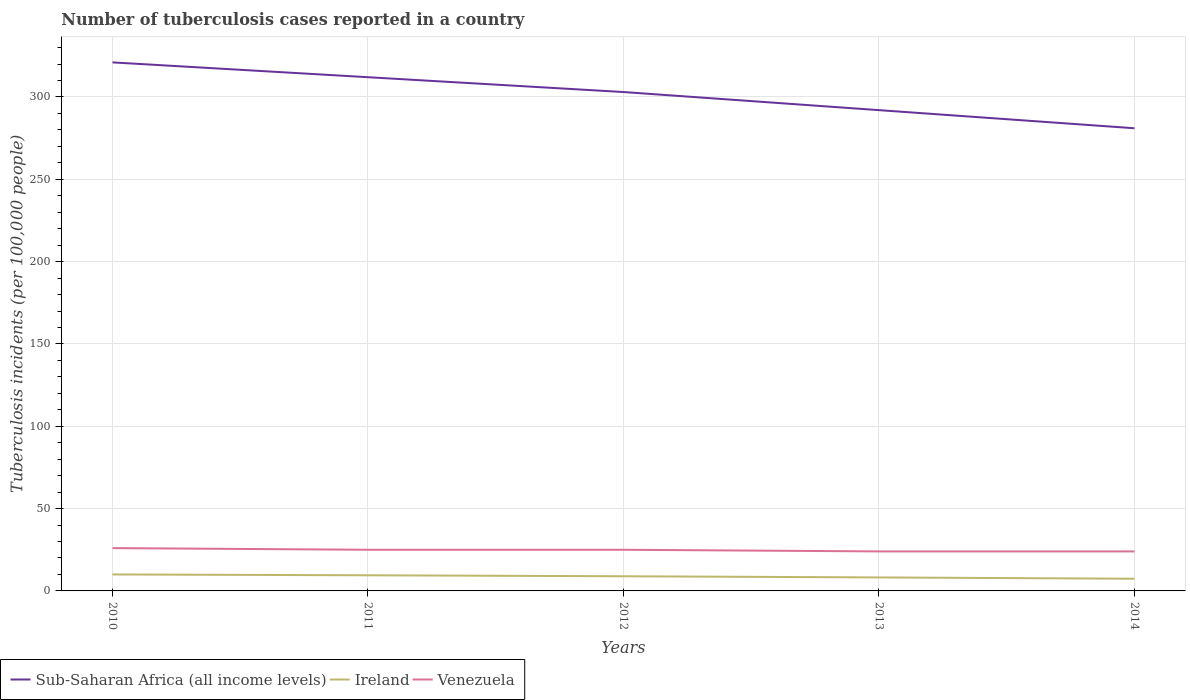Across all years, what is the maximum number of tuberculosis cases reported in in Sub-Saharan Africa (all income levels)?
Offer a terse response. 281. What is the total number of tuberculosis cases reported in in Sub-Saharan Africa (all income levels) in the graph?
Your answer should be compact. 9. What is the difference between the highest and the second highest number of tuberculosis cases reported in in Sub-Saharan Africa (all income levels)?
Your response must be concise. 40. What is the difference between the highest and the lowest number of tuberculosis cases reported in in Ireland?
Your response must be concise. 3. Is the number of tuberculosis cases reported in in Venezuela strictly greater than the number of tuberculosis cases reported in in Sub-Saharan Africa (all income levels) over the years?
Your answer should be very brief. Yes. How many years are there in the graph?
Make the answer very short. 5. What is the difference between two consecutive major ticks on the Y-axis?
Offer a very short reply. 50. How many legend labels are there?
Offer a terse response. 3. What is the title of the graph?
Provide a short and direct response. Number of tuberculosis cases reported in a country. Does "Togo" appear as one of the legend labels in the graph?
Keep it short and to the point. No. What is the label or title of the Y-axis?
Your response must be concise. Tuberculosis incidents (per 100,0 people). What is the Tuberculosis incidents (per 100,000 people) of Sub-Saharan Africa (all income levels) in 2010?
Give a very brief answer. 321. What is the Tuberculosis incidents (per 100,000 people) in Sub-Saharan Africa (all income levels) in 2011?
Keep it short and to the point. 312. What is the Tuberculosis incidents (per 100,000 people) of Ireland in 2011?
Provide a succinct answer. 9.5. What is the Tuberculosis incidents (per 100,000 people) of Sub-Saharan Africa (all income levels) in 2012?
Offer a terse response. 303. What is the Tuberculosis incidents (per 100,000 people) in Sub-Saharan Africa (all income levels) in 2013?
Provide a short and direct response. 292. What is the Tuberculosis incidents (per 100,000 people) of Ireland in 2013?
Offer a terse response. 8.2. What is the Tuberculosis incidents (per 100,000 people) in Venezuela in 2013?
Provide a short and direct response. 24. What is the Tuberculosis incidents (per 100,000 people) in Sub-Saharan Africa (all income levels) in 2014?
Make the answer very short. 281. Across all years, what is the maximum Tuberculosis incidents (per 100,000 people) in Sub-Saharan Africa (all income levels)?
Make the answer very short. 321. Across all years, what is the maximum Tuberculosis incidents (per 100,000 people) in Venezuela?
Provide a short and direct response. 26. Across all years, what is the minimum Tuberculosis incidents (per 100,000 people) in Sub-Saharan Africa (all income levels)?
Make the answer very short. 281. What is the total Tuberculosis incidents (per 100,000 people) of Sub-Saharan Africa (all income levels) in the graph?
Offer a very short reply. 1509. What is the total Tuberculosis incidents (per 100,000 people) of Venezuela in the graph?
Your response must be concise. 124. What is the difference between the Tuberculosis incidents (per 100,000 people) in Ireland in 2010 and that in 2011?
Your answer should be compact. 0.5. What is the difference between the Tuberculosis incidents (per 100,000 people) of Sub-Saharan Africa (all income levels) in 2010 and that in 2013?
Your response must be concise. 29. What is the difference between the Tuberculosis incidents (per 100,000 people) of Ireland in 2010 and that in 2013?
Keep it short and to the point. 1.8. What is the difference between the Tuberculosis incidents (per 100,000 people) of Sub-Saharan Africa (all income levels) in 2010 and that in 2014?
Offer a terse response. 40. What is the difference between the Tuberculosis incidents (per 100,000 people) in Sub-Saharan Africa (all income levels) in 2011 and that in 2012?
Give a very brief answer. 9. What is the difference between the Tuberculosis incidents (per 100,000 people) in Venezuela in 2011 and that in 2012?
Your answer should be very brief. 0. What is the difference between the Tuberculosis incidents (per 100,000 people) of Venezuela in 2011 and that in 2013?
Provide a succinct answer. 1. What is the difference between the Tuberculosis incidents (per 100,000 people) in Sub-Saharan Africa (all income levels) in 2011 and that in 2014?
Give a very brief answer. 31. What is the difference between the Tuberculosis incidents (per 100,000 people) of Venezuela in 2011 and that in 2014?
Your answer should be compact. 1. What is the difference between the Tuberculosis incidents (per 100,000 people) in Venezuela in 2012 and that in 2014?
Your response must be concise. 1. What is the difference between the Tuberculosis incidents (per 100,000 people) of Sub-Saharan Africa (all income levels) in 2013 and that in 2014?
Offer a very short reply. 11. What is the difference between the Tuberculosis incidents (per 100,000 people) of Ireland in 2013 and that in 2014?
Your answer should be compact. 0.8. What is the difference between the Tuberculosis incidents (per 100,000 people) of Venezuela in 2013 and that in 2014?
Your response must be concise. 0. What is the difference between the Tuberculosis incidents (per 100,000 people) in Sub-Saharan Africa (all income levels) in 2010 and the Tuberculosis incidents (per 100,000 people) in Ireland in 2011?
Make the answer very short. 311.5. What is the difference between the Tuberculosis incidents (per 100,000 people) of Sub-Saharan Africa (all income levels) in 2010 and the Tuberculosis incidents (per 100,000 people) of Venezuela in 2011?
Give a very brief answer. 296. What is the difference between the Tuberculosis incidents (per 100,000 people) in Ireland in 2010 and the Tuberculosis incidents (per 100,000 people) in Venezuela in 2011?
Your answer should be compact. -15. What is the difference between the Tuberculosis incidents (per 100,000 people) in Sub-Saharan Africa (all income levels) in 2010 and the Tuberculosis incidents (per 100,000 people) in Ireland in 2012?
Your answer should be compact. 312.1. What is the difference between the Tuberculosis incidents (per 100,000 people) of Sub-Saharan Africa (all income levels) in 2010 and the Tuberculosis incidents (per 100,000 people) of Venezuela in 2012?
Offer a terse response. 296. What is the difference between the Tuberculosis incidents (per 100,000 people) in Sub-Saharan Africa (all income levels) in 2010 and the Tuberculosis incidents (per 100,000 people) in Ireland in 2013?
Ensure brevity in your answer.  312.8. What is the difference between the Tuberculosis incidents (per 100,000 people) in Sub-Saharan Africa (all income levels) in 2010 and the Tuberculosis incidents (per 100,000 people) in Venezuela in 2013?
Provide a succinct answer. 297. What is the difference between the Tuberculosis incidents (per 100,000 people) in Ireland in 2010 and the Tuberculosis incidents (per 100,000 people) in Venezuela in 2013?
Keep it short and to the point. -14. What is the difference between the Tuberculosis incidents (per 100,000 people) in Sub-Saharan Africa (all income levels) in 2010 and the Tuberculosis incidents (per 100,000 people) in Ireland in 2014?
Your response must be concise. 313.6. What is the difference between the Tuberculosis incidents (per 100,000 people) in Sub-Saharan Africa (all income levels) in 2010 and the Tuberculosis incidents (per 100,000 people) in Venezuela in 2014?
Your response must be concise. 297. What is the difference between the Tuberculosis incidents (per 100,000 people) of Sub-Saharan Africa (all income levels) in 2011 and the Tuberculosis incidents (per 100,000 people) of Ireland in 2012?
Provide a short and direct response. 303.1. What is the difference between the Tuberculosis incidents (per 100,000 people) of Sub-Saharan Africa (all income levels) in 2011 and the Tuberculosis incidents (per 100,000 people) of Venezuela in 2012?
Your answer should be compact. 287. What is the difference between the Tuberculosis incidents (per 100,000 people) of Ireland in 2011 and the Tuberculosis incidents (per 100,000 people) of Venezuela in 2012?
Your answer should be compact. -15.5. What is the difference between the Tuberculosis incidents (per 100,000 people) in Sub-Saharan Africa (all income levels) in 2011 and the Tuberculosis incidents (per 100,000 people) in Ireland in 2013?
Ensure brevity in your answer.  303.8. What is the difference between the Tuberculosis incidents (per 100,000 people) of Sub-Saharan Africa (all income levels) in 2011 and the Tuberculosis incidents (per 100,000 people) of Venezuela in 2013?
Your answer should be very brief. 288. What is the difference between the Tuberculosis incidents (per 100,000 people) in Sub-Saharan Africa (all income levels) in 2011 and the Tuberculosis incidents (per 100,000 people) in Ireland in 2014?
Make the answer very short. 304.6. What is the difference between the Tuberculosis incidents (per 100,000 people) in Sub-Saharan Africa (all income levels) in 2011 and the Tuberculosis incidents (per 100,000 people) in Venezuela in 2014?
Make the answer very short. 288. What is the difference between the Tuberculosis incidents (per 100,000 people) of Ireland in 2011 and the Tuberculosis incidents (per 100,000 people) of Venezuela in 2014?
Make the answer very short. -14.5. What is the difference between the Tuberculosis incidents (per 100,000 people) of Sub-Saharan Africa (all income levels) in 2012 and the Tuberculosis incidents (per 100,000 people) of Ireland in 2013?
Your response must be concise. 294.8. What is the difference between the Tuberculosis incidents (per 100,000 people) in Sub-Saharan Africa (all income levels) in 2012 and the Tuberculosis incidents (per 100,000 people) in Venezuela in 2013?
Provide a short and direct response. 279. What is the difference between the Tuberculosis incidents (per 100,000 people) in Ireland in 2012 and the Tuberculosis incidents (per 100,000 people) in Venezuela in 2013?
Keep it short and to the point. -15.1. What is the difference between the Tuberculosis incidents (per 100,000 people) in Sub-Saharan Africa (all income levels) in 2012 and the Tuberculosis incidents (per 100,000 people) in Ireland in 2014?
Your answer should be very brief. 295.6. What is the difference between the Tuberculosis incidents (per 100,000 people) of Sub-Saharan Africa (all income levels) in 2012 and the Tuberculosis incidents (per 100,000 people) of Venezuela in 2014?
Give a very brief answer. 279. What is the difference between the Tuberculosis incidents (per 100,000 people) of Ireland in 2012 and the Tuberculosis incidents (per 100,000 people) of Venezuela in 2014?
Your answer should be very brief. -15.1. What is the difference between the Tuberculosis incidents (per 100,000 people) in Sub-Saharan Africa (all income levels) in 2013 and the Tuberculosis incidents (per 100,000 people) in Ireland in 2014?
Keep it short and to the point. 284.6. What is the difference between the Tuberculosis incidents (per 100,000 people) of Sub-Saharan Africa (all income levels) in 2013 and the Tuberculosis incidents (per 100,000 people) of Venezuela in 2014?
Provide a succinct answer. 268. What is the difference between the Tuberculosis incidents (per 100,000 people) of Ireland in 2013 and the Tuberculosis incidents (per 100,000 people) of Venezuela in 2014?
Make the answer very short. -15.8. What is the average Tuberculosis incidents (per 100,000 people) of Sub-Saharan Africa (all income levels) per year?
Your response must be concise. 301.8. What is the average Tuberculosis incidents (per 100,000 people) in Venezuela per year?
Keep it short and to the point. 24.8. In the year 2010, what is the difference between the Tuberculosis incidents (per 100,000 people) of Sub-Saharan Africa (all income levels) and Tuberculosis incidents (per 100,000 people) of Ireland?
Your response must be concise. 311. In the year 2010, what is the difference between the Tuberculosis incidents (per 100,000 people) of Sub-Saharan Africa (all income levels) and Tuberculosis incidents (per 100,000 people) of Venezuela?
Ensure brevity in your answer.  295. In the year 2011, what is the difference between the Tuberculosis incidents (per 100,000 people) in Sub-Saharan Africa (all income levels) and Tuberculosis incidents (per 100,000 people) in Ireland?
Ensure brevity in your answer.  302.5. In the year 2011, what is the difference between the Tuberculosis incidents (per 100,000 people) in Sub-Saharan Africa (all income levels) and Tuberculosis incidents (per 100,000 people) in Venezuela?
Give a very brief answer. 287. In the year 2011, what is the difference between the Tuberculosis incidents (per 100,000 people) in Ireland and Tuberculosis incidents (per 100,000 people) in Venezuela?
Ensure brevity in your answer.  -15.5. In the year 2012, what is the difference between the Tuberculosis incidents (per 100,000 people) of Sub-Saharan Africa (all income levels) and Tuberculosis incidents (per 100,000 people) of Ireland?
Your answer should be compact. 294.1. In the year 2012, what is the difference between the Tuberculosis incidents (per 100,000 people) in Sub-Saharan Africa (all income levels) and Tuberculosis incidents (per 100,000 people) in Venezuela?
Give a very brief answer. 278. In the year 2012, what is the difference between the Tuberculosis incidents (per 100,000 people) in Ireland and Tuberculosis incidents (per 100,000 people) in Venezuela?
Offer a terse response. -16.1. In the year 2013, what is the difference between the Tuberculosis incidents (per 100,000 people) of Sub-Saharan Africa (all income levels) and Tuberculosis incidents (per 100,000 people) of Ireland?
Offer a terse response. 283.8. In the year 2013, what is the difference between the Tuberculosis incidents (per 100,000 people) in Sub-Saharan Africa (all income levels) and Tuberculosis incidents (per 100,000 people) in Venezuela?
Your answer should be very brief. 268. In the year 2013, what is the difference between the Tuberculosis incidents (per 100,000 people) of Ireland and Tuberculosis incidents (per 100,000 people) of Venezuela?
Offer a terse response. -15.8. In the year 2014, what is the difference between the Tuberculosis incidents (per 100,000 people) of Sub-Saharan Africa (all income levels) and Tuberculosis incidents (per 100,000 people) of Ireland?
Your answer should be very brief. 273.6. In the year 2014, what is the difference between the Tuberculosis incidents (per 100,000 people) in Sub-Saharan Africa (all income levels) and Tuberculosis incidents (per 100,000 people) in Venezuela?
Provide a succinct answer. 257. In the year 2014, what is the difference between the Tuberculosis incidents (per 100,000 people) of Ireland and Tuberculosis incidents (per 100,000 people) of Venezuela?
Ensure brevity in your answer.  -16.6. What is the ratio of the Tuberculosis incidents (per 100,000 people) of Sub-Saharan Africa (all income levels) in 2010 to that in 2011?
Your answer should be compact. 1.03. What is the ratio of the Tuberculosis incidents (per 100,000 people) in Ireland in 2010 to that in 2011?
Ensure brevity in your answer.  1.05. What is the ratio of the Tuberculosis incidents (per 100,000 people) in Sub-Saharan Africa (all income levels) in 2010 to that in 2012?
Ensure brevity in your answer.  1.06. What is the ratio of the Tuberculosis incidents (per 100,000 people) of Ireland in 2010 to that in 2012?
Provide a succinct answer. 1.12. What is the ratio of the Tuberculosis incidents (per 100,000 people) of Sub-Saharan Africa (all income levels) in 2010 to that in 2013?
Offer a terse response. 1.1. What is the ratio of the Tuberculosis incidents (per 100,000 people) in Ireland in 2010 to that in 2013?
Provide a succinct answer. 1.22. What is the ratio of the Tuberculosis incidents (per 100,000 people) in Sub-Saharan Africa (all income levels) in 2010 to that in 2014?
Offer a terse response. 1.14. What is the ratio of the Tuberculosis incidents (per 100,000 people) of Ireland in 2010 to that in 2014?
Keep it short and to the point. 1.35. What is the ratio of the Tuberculosis incidents (per 100,000 people) of Venezuela in 2010 to that in 2014?
Provide a succinct answer. 1.08. What is the ratio of the Tuberculosis incidents (per 100,000 people) in Sub-Saharan Africa (all income levels) in 2011 to that in 2012?
Your answer should be very brief. 1.03. What is the ratio of the Tuberculosis incidents (per 100,000 people) in Ireland in 2011 to that in 2012?
Your answer should be very brief. 1.07. What is the ratio of the Tuberculosis incidents (per 100,000 people) of Sub-Saharan Africa (all income levels) in 2011 to that in 2013?
Offer a terse response. 1.07. What is the ratio of the Tuberculosis incidents (per 100,000 people) of Ireland in 2011 to that in 2013?
Give a very brief answer. 1.16. What is the ratio of the Tuberculosis incidents (per 100,000 people) in Venezuela in 2011 to that in 2013?
Provide a short and direct response. 1.04. What is the ratio of the Tuberculosis incidents (per 100,000 people) in Sub-Saharan Africa (all income levels) in 2011 to that in 2014?
Your response must be concise. 1.11. What is the ratio of the Tuberculosis incidents (per 100,000 people) in Ireland in 2011 to that in 2014?
Offer a terse response. 1.28. What is the ratio of the Tuberculosis incidents (per 100,000 people) of Venezuela in 2011 to that in 2014?
Offer a very short reply. 1.04. What is the ratio of the Tuberculosis incidents (per 100,000 people) in Sub-Saharan Africa (all income levels) in 2012 to that in 2013?
Make the answer very short. 1.04. What is the ratio of the Tuberculosis incidents (per 100,000 people) in Ireland in 2012 to that in 2013?
Offer a very short reply. 1.09. What is the ratio of the Tuberculosis incidents (per 100,000 people) of Venezuela in 2012 to that in 2013?
Your answer should be compact. 1.04. What is the ratio of the Tuberculosis incidents (per 100,000 people) in Sub-Saharan Africa (all income levels) in 2012 to that in 2014?
Offer a terse response. 1.08. What is the ratio of the Tuberculosis incidents (per 100,000 people) in Ireland in 2012 to that in 2014?
Provide a succinct answer. 1.2. What is the ratio of the Tuberculosis incidents (per 100,000 people) in Venezuela in 2012 to that in 2014?
Offer a terse response. 1.04. What is the ratio of the Tuberculosis incidents (per 100,000 people) of Sub-Saharan Africa (all income levels) in 2013 to that in 2014?
Provide a succinct answer. 1.04. What is the ratio of the Tuberculosis incidents (per 100,000 people) in Ireland in 2013 to that in 2014?
Offer a terse response. 1.11. What is the ratio of the Tuberculosis incidents (per 100,000 people) in Venezuela in 2013 to that in 2014?
Make the answer very short. 1. What is the difference between the highest and the second highest Tuberculosis incidents (per 100,000 people) of Sub-Saharan Africa (all income levels)?
Provide a succinct answer. 9. What is the difference between the highest and the second highest Tuberculosis incidents (per 100,000 people) of Ireland?
Your response must be concise. 0.5. What is the difference between the highest and the second highest Tuberculosis incidents (per 100,000 people) of Venezuela?
Your answer should be very brief. 1. What is the difference between the highest and the lowest Tuberculosis incidents (per 100,000 people) in Sub-Saharan Africa (all income levels)?
Your response must be concise. 40. What is the difference between the highest and the lowest Tuberculosis incidents (per 100,000 people) of Venezuela?
Provide a short and direct response. 2. 